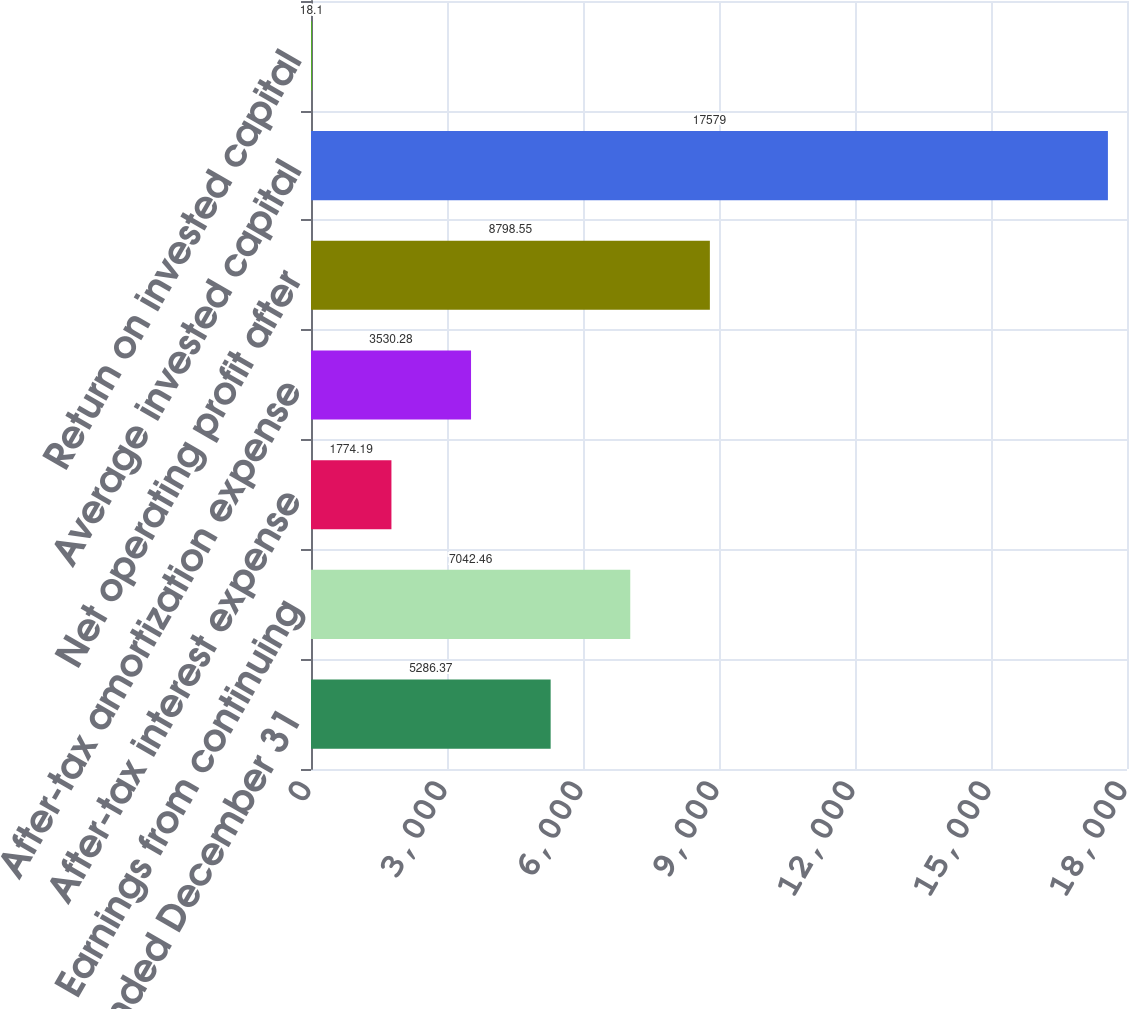Convert chart to OTSL. <chart><loc_0><loc_0><loc_500><loc_500><bar_chart><fcel>Year Ended December 31<fcel>Earnings from continuing<fcel>After-tax interest expense<fcel>After-tax amortization expense<fcel>Net operating profit after<fcel>Average invested capital<fcel>Return on invested capital<nl><fcel>5286.37<fcel>7042.46<fcel>1774.19<fcel>3530.28<fcel>8798.55<fcel>17579<fcel>18.1<nl></chart> 